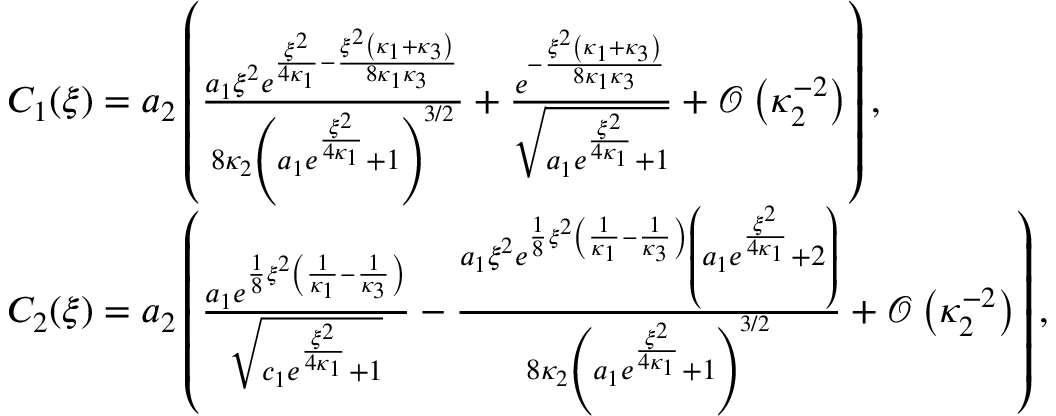Convert formula to latex. <formula><loc_0><loc_0><loc_500><loc_500>\begin{array} { r l } & { C _ { 1 } ( \xi ) = a _ { 2 } \left ( \frac { a _ { 1 } \xi ^ { 2 } e ^ { \frac { \xi ^ { 2 } } { 4 \kappa _ { 1 } } - \frac { \xi ^ { 2 } \left ( \kappa _ { 1 } + \kappa _ { 3 } \right ) } { 8 \kappa _ { 1 } \kappa _ { 3 } } } } { 8 \kappa _ { 2 } \left ( a _ { 1 } e ^ { \frac { \xi ^ { 2 } } { 4 \kappa _ { 1 } } } + 1 \right ) ^ { 3 / 2 } } + \frac { e ^ { - \frac { \xi ^ { 2 } \left ( \kappa _ { 1 } + \kappa _ { 3 } \right ) } { 8 \kappa _ { 1 } \kappa _ { 3 } } } } { \sqrt { a _ { 1 } e ^ { \frac { \xi ^ { 2 } } { 4 \kappa _ { 1 } } } + 1 } } + \mathcal { O } \left ( \kappa _ { 2 } ^ { - 2 } \right ) \right ) , } \\ & { C _ { 2 } ( \xi ) = a _ { 2 } \left ( \frac { a _ { 1 } e ^ { \frac { 1 } { 8 } \xi ^ { 2 } \left ( \frac { 1 } { \kappa _ { 1 } } - \frac { 1 } { \kappa _ { 3 } } \right ) } } { \sqrt { c _ { 1 } e ^ { \frac { \xi ^ { 2 } } { 4 \kappa _ { 1 } } } + 1 } } - \frac { a _ { 1 } \xi ^ { 2 } e ^ { \frac { 1 } { 8 } \xi ^ { 2 } \left ( \frac { 1 } { \kappa _ { 1 } } - \frac { 1 } { \kappa _ { 3 } } \right ) } \left ( a _ { 1 } e ^ { \frac { \xi ^ { 2 } } { 4 \kappa _ { 1 } } } + 2 \right ) } { 8 \kappa _ { 2 } \left ( a _ { 1 } e ^ { \frac { \xi ^ { 2 } } { 4 \kappa _ { 1 } } } + 1 \right ) ^ { 3 / 2 } } + \mathcal { O } \left ( \kappa _ { 2 } ^ { - 2 } \right ) \right ) , } \end{array}</formula> 